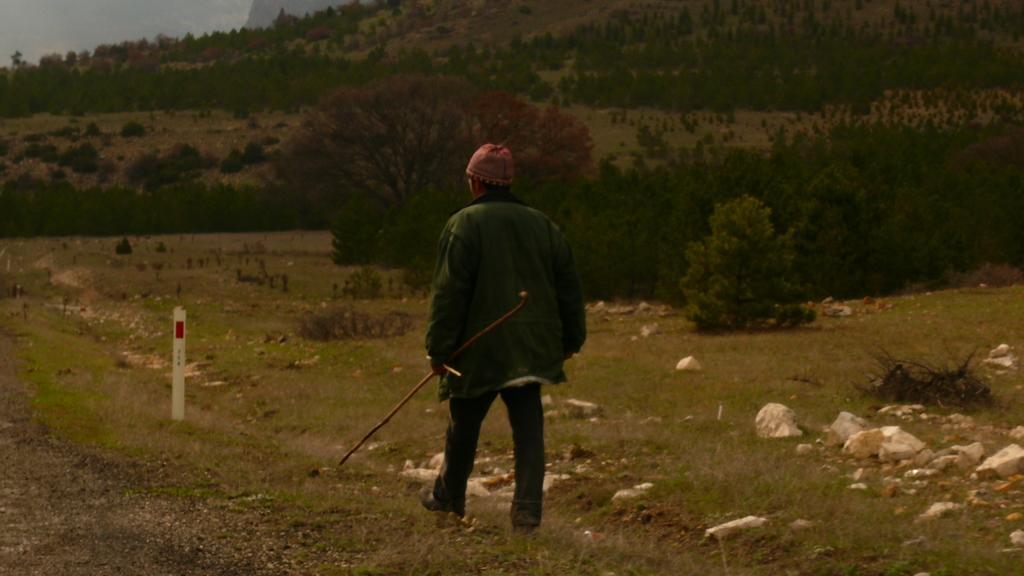In one or two sentences, can you explain what this image depicts? In this image there is a person walking on the surface of the grass and he is holding a stick in his hand, there is an object and a few rocks on the surface. In the background there are trees and plants. 